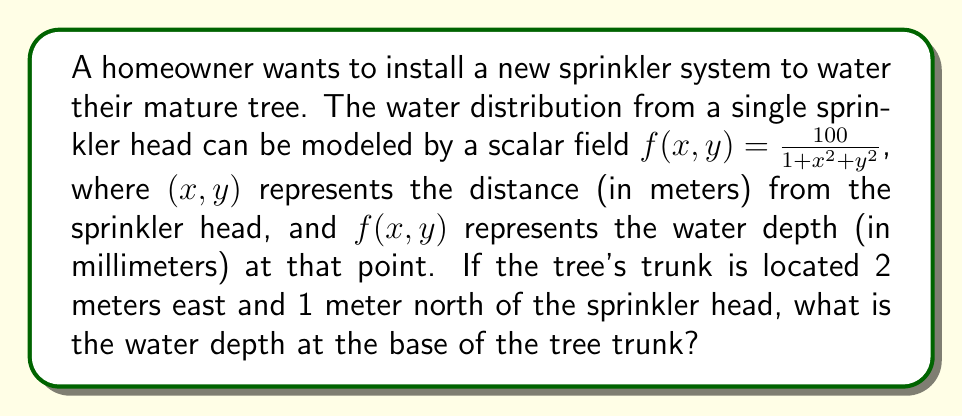Give your solution to this math problem. To solve this problem, we need to follow these steps:

1. Identify the coordinates of the tree trunk relative to the sprinkler head:
   The tree trunk is 2 meters east (x-direction) and 1 meter north (y-direction).
   So, the coordinates are (x, y) = (2, 1).

2. Substitute these coordinates into the scalar field equation:
   $$f(x,y) = \frac{100}{1 + x^2 + y^2}$$
   $$f(2,1) = \frac{100}{1 + 2^2 + 1^2}$$

3. Simplify the expression:
   $$f(2,1) = \frac{100}{1 + 4 + 1} = \frac{100}{6}$$

4. Calculate the final result:
   $$f(2,1) = \frac{100}{6} \approx 16.67$$

Therefore, the water depth at the base of the tree trunk is approximately 16.67 millimeters.
Answer: 16.67 mm 